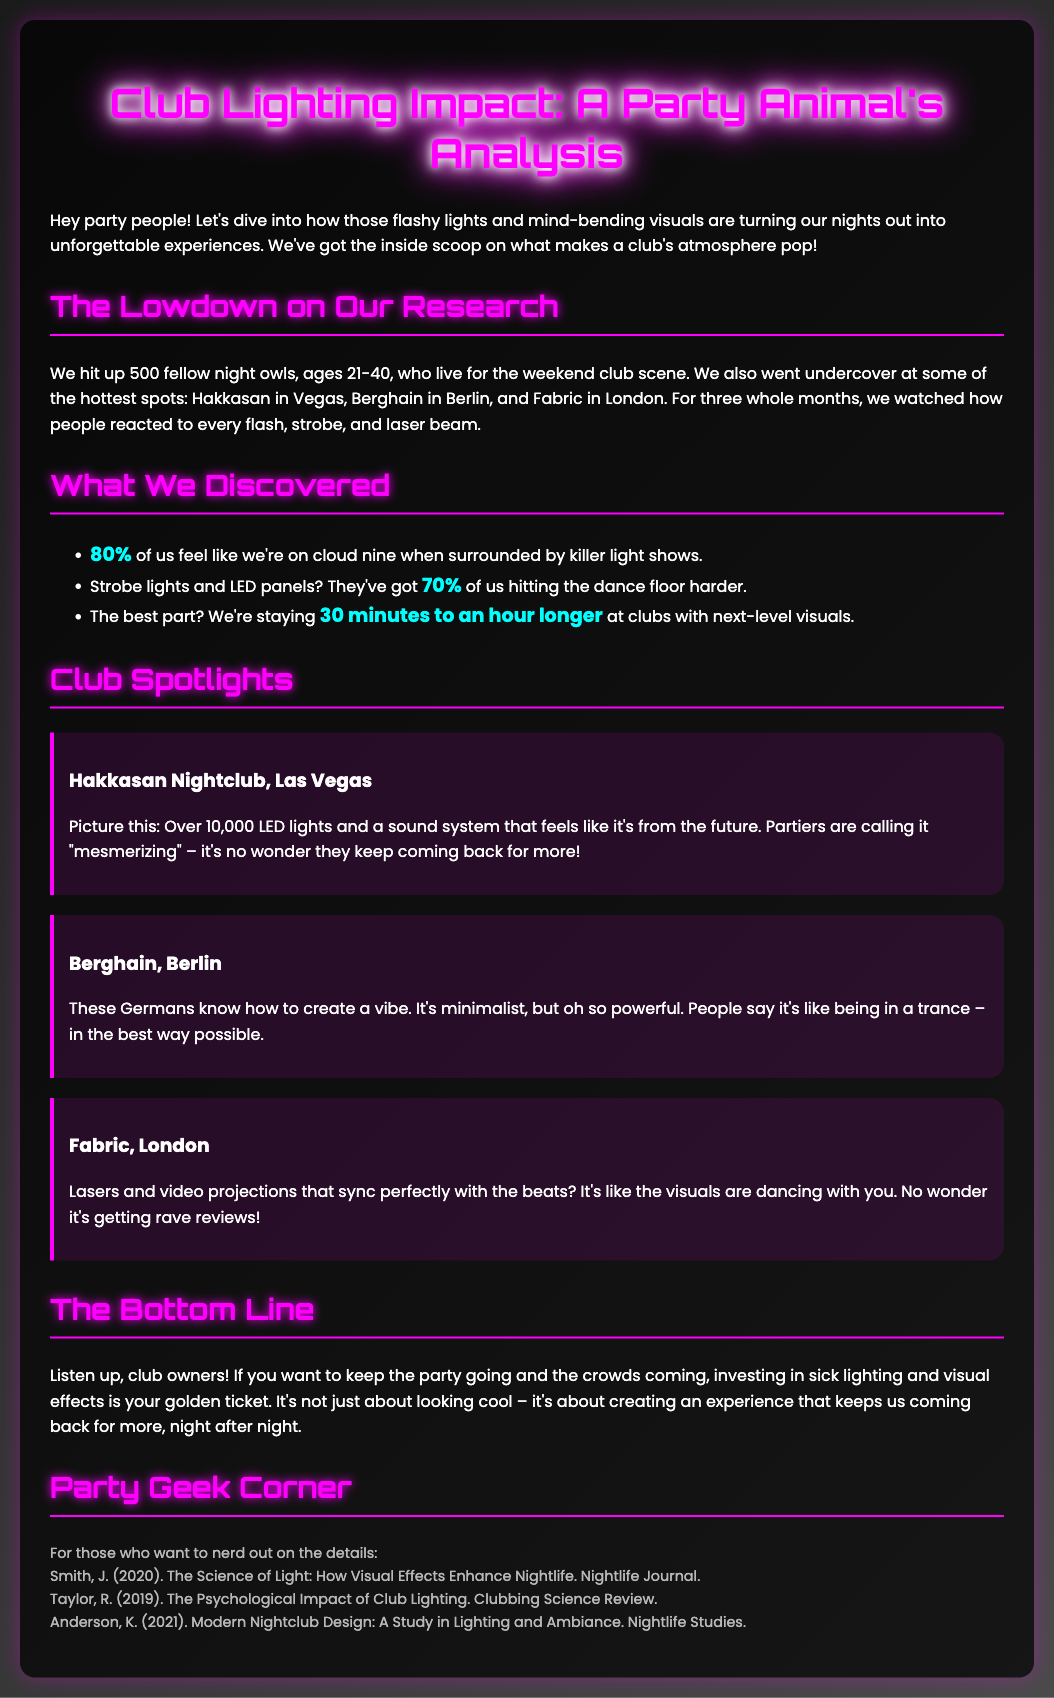what percentage of respondents feel elevated by light shows? The document states that 80% of club goers feel like they're on cloud nine when surrounded by killer light shows.
Answer: 80% which city is Hakkasan located in? Hakkasan is mentioned as being in Las Vegas.
Answer: Las Vegas how much longer do patrons stay at clubs with next-level visuals? The report indicates that patrons stay 30 minutes to an hour longer at such clubs.
Answer: 30 minutes to an hour longer what is the main takeaway for club owners? The document emphasizes that investing in lighting and visual effects is crucial for keeping the party going and attracting crowds.
Answer: Investing in lighting and visual effects name one type of lighting that encourages more dancing. The text mentions strobe lights and LED panels that have encouraged more dancing.
Answer: Strobe lights and LED panels what did people describe the Berghain vibe as? The document states that people say it's like being in a trance.
Answer: Like being in a trance who authored a study on the psychological impact of club lighting? The document lists Taylor, R. as the author behind this study.
Answer: Taylor, R what key element did respondents associate with enhanced club experiences? The findings suggest that respondents associate lighting effects with enhanced club experiences.
Answer: Lighting effects how many fellow night owls did the research involve? The research involved 500 fellow night owls, as indicated in the document.
Answer: 500 